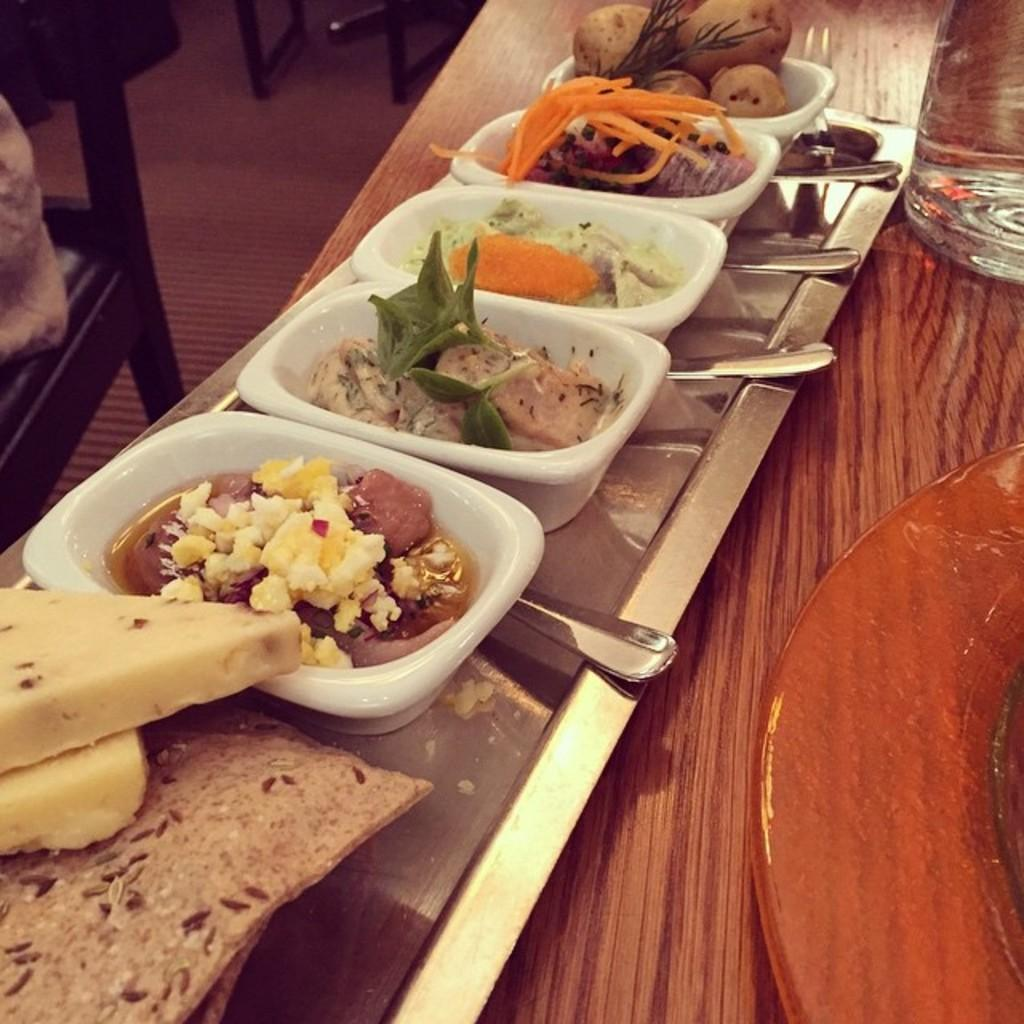What type of containers are present in the image? There are bowls in the image. What is inside the containers? There is food in the image. What specific type of food can be seen? There are vegetables in the image. What is used to carry or hold the bowls and other objects? There is a tray in the image. What is the surface on which the tray and other objects are placed? The table is visible in the image. Can you describe the floor in the image? The floor is visible in the image. How many chairs are present in the image? There is at least one chair in the image. Are there any objects associated with the chair or floor? Yes, there are objects associated with the chair or floor. What type of chain can be seen hanging from the ceiling in the image? There is no chain hanging from the ceiling in the image. 